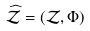<formula> <loc_0><loc_0><loc_500><loc_500>\widehat { \mathcal { Z } } = ( \mathcal { Z } , \Phi )</formula> 